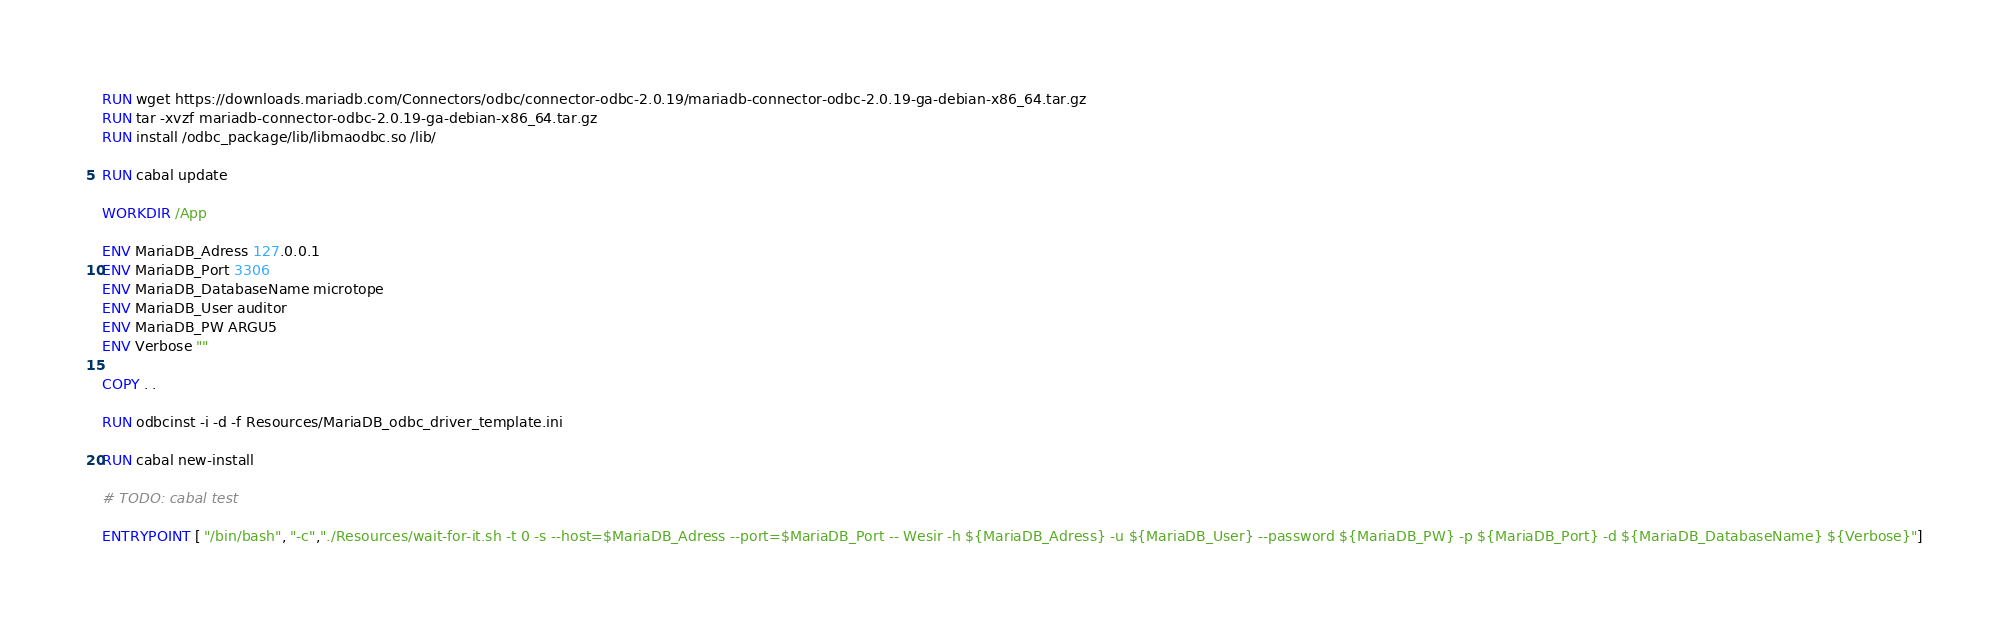Convert code to text. <code><loc_0><loc_0><loc_500><loc_500><_Dockerfile_>RUN wget https://downloads.mariadb.com/Connectors/odbc/connector-odbc-2.0.19/mariadb-connector-odbc-2.0.19-ga-debian-x86_64.tar.gz
RUN tar -xvzf mariadb-connector-odbc-2.0.19-ga-debian-x86_64.tar.gz
RUN install /odbc_package/lib/libmaodbc.so /lib/

RUN cabal update

WORKDIR /App

ENV MariaDB_Adress 127.0.0.1
ENV MariaDB_Port 3306
ENV MariaDB_DatabaseName microtope
ENV MariaDB_User auditor
ENV MariaDB_PW ARGU5
ENV Verbose ""

COPY . .

RUN odbcinst -i -d -f Resources/MariaDB_odbc_driver_template.ini

RUN cabal new-install 

# TODO: cabal test

ENTRYPOINT [ "/bin/bash", "-c","./Resources/wait-for-it.sh -t 0 -s --host=$MariaDB_Adress --port=$MariaDB_Port -- Wesir -h ${MariaDB_Adress} -u ${MariaDB_User} --password ${MariaDB_PW} -p ${MariaDB_Port} -d ${MariaDB_DatabaseName} ${Verbose}"]</code> 